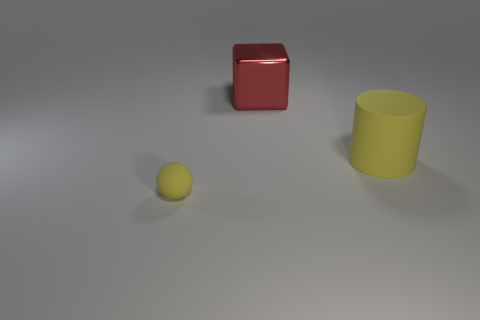There is a matte object in front of the big yellow cylinder; is its color the same as the matte thing that is behind the yellow ball?
Your answer should be very brief. Yes. Does the yellow thing that is behind the small yellow matte thing have the same size as the rubber thing to the left of the large red thing?
Your answer should be compact. No. Is there anything else that has the same material as the cube?
Keep it short and to the point. No. The yellow object to the left of the yellow rubber thing on the right side of the yellow matte thing to the left of the large yellow rubber object is made of what material?
Ensure brevity in your answer.  Rubber. There is another object that is the same material as the large yellow object; what is its size?
Give a very brief answer. Small. What number of big metallic things are in front of the yellow rubber thing left of the large shiny object?
Offer a terse response. 0. Is the number of large red shiny things in front of the tiny object greater than the number of yellow rubber cylinders that are behind the shiny object?
Keep it short and to the point. No. What is the material of the thing that is the same size as the yellow rubber cylinder?
Give a very brief answer. Metal. What size is the yellow thing that is left of the large red block?
Make the answer very short. Small. There is a thing that is both behind the small yellow matte object and in front of the large metallic block; what shape is it?
Your response must be concise. Cylinder. 